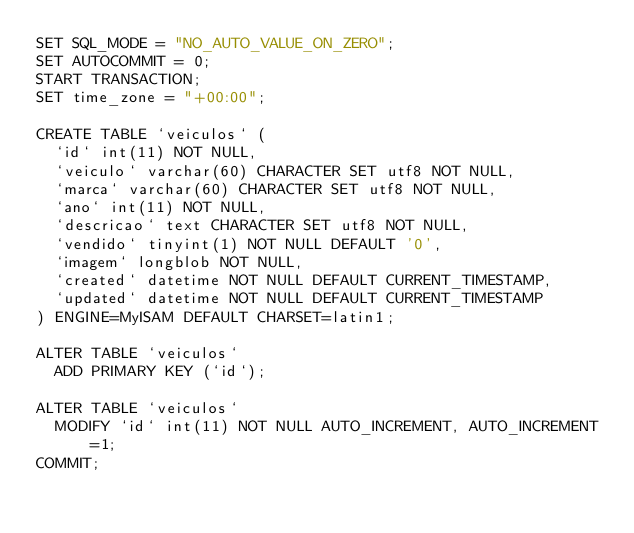<code> <loc_0><loc_0><loc_500><loc_500><_SQL_>SET SQL_MODE = "NO_AUTO_VALUE_ON_ZERO";
SET AUTOCOMMIT = 0;
START TRANSACTION;
SET time_zone = "+00:00";

CREATE TABLE `veiculos` (
  `id` int(11) NOT NULL,
  `veiculo` varchar(60) CHARACTER SET utf8 NOT NULL,
  `marca` varchar(60) CHARACTER SET utf8 NOT NULL,
  `ano` int(11) NOT NULL,
  `descricao` text CHARACTER SET utf8 NOT NULL,
  `vendido` tinyint(1) NOT NULL DEFAULT '0',
  `imagem` longblob NOT NULL,
  `created` datetime NOT NULL DEFAULT CURRENT_TIMESTAMP,
  `updated` datetime NOT NULL DEFAULT CURRENT_TIMESTAMP
) ENGINE=MyISAM DEFAULT CHARSET=latin1;

ALTER TABLE `veiculos`
  ADD PRIMARY KEY (`id`);

ALTER TABLE `veiculos`
  MODIFY `id` int(11) NOT NULL AUTO_INCREMENT, AUTO_INCREMENT=1;
COMMIT;
</code> 